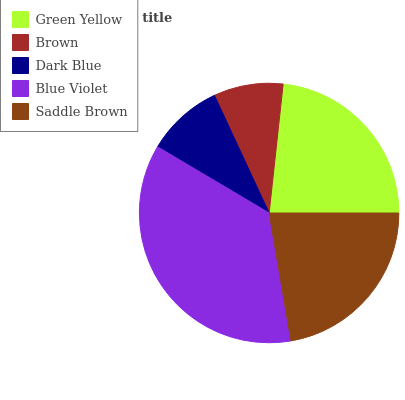Is Brown the minimum?
Answer yes or no. Yes. Is Blue Violet the maximum?
Answer yes or no. Yes. Is Dark Blue the minimum?
Answer yes or no. No. Is Dark Blue the maximum?
Answer yes or no. No. Is Dark Blue greater than Brown?
Answer yes or no. Yes. Is Brown less than Dark Blue?
Answer yes or no. Yes. Is Brown greater than Dark Blue?
Answer yes or no. No. Is Dark Blue less than Brown?
Answer yes or no. No. Is Saddle Brown the high median?
Answer yes or no. Yes. Is Saddle Brown the low median?
Answer yes or no. Yes. Is Green Yellow the high median?
Answer yes or no. No. Is Brown the low median?
Answer yes or no. No. 